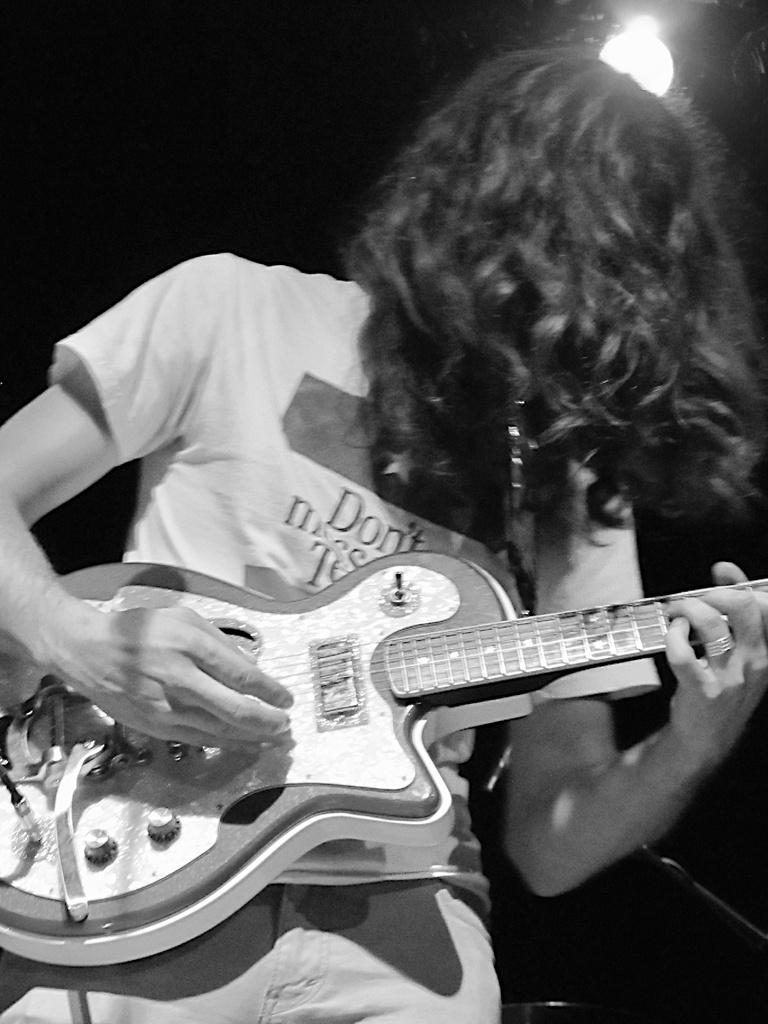What is the color scheme of the image? The image is black and white. What is the main subject of the image? There is a person in the image. What is the person doing in the image? The person is playing a guitar. Can you describe any other elements in the image? There is a focusing light in the image. How many dogs are visible in the image? There are no dogs present in the image. What time does the watch in the image show? There is no watch present in the image. 